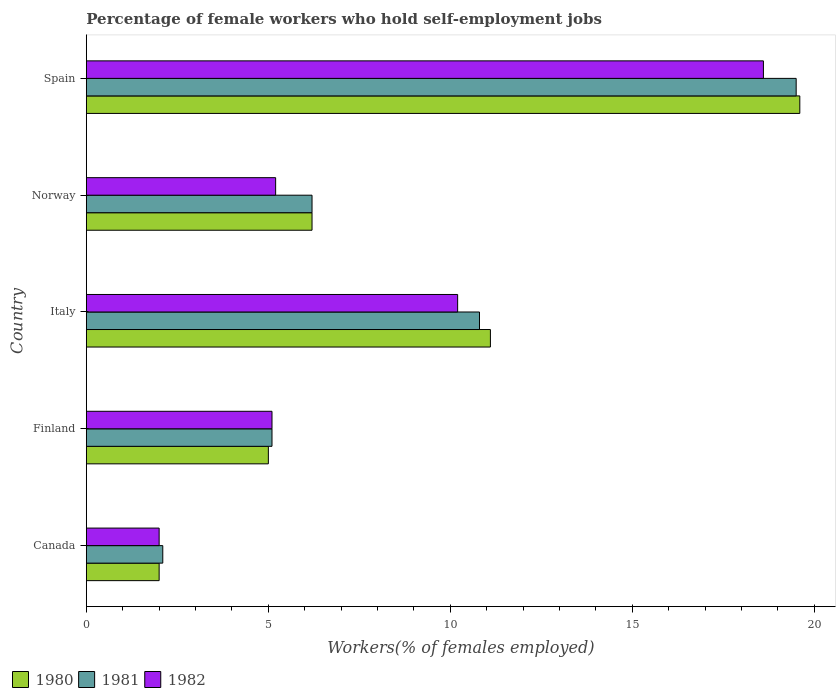Are the number of bars per tick equal to the number of legend labels?
Offer a very short reply. Yes. Are the number of bars on each tick of the Y-axis equal?
Offer a very short reply. Yes. How many bars are there on the 5th tick from the top?
Give a very brief answer. 3. What is the label of the 3rd group of bars from the top?
Provide a short and direct response. Italy. What is the percentage of self-employed female workers in 1981 in Finland?
Give a very brief answer. 5.1. In which country was the percentage of self-employed female workers in 1980 maximum?
Keep it short and to the point. Spain. What is the total percentage of self-employed female workers in 1982 in the graph?
Provide a succinct answer. 41.1. What is the difference between the percentage of self-employed female workers in 1981 in Canada and that in Finland?
Offer a very short reply. -3. What is the difference between the percentage of self-employed female workers in 1981 in Norway and the percentage of self-employed female workers in 1980 in Finland?
Your answer should be very brief. 1.2. What is the average percentage of self-employed female workers in 1980 per country?
Your answer should be compact. 8.78. What is the difference between the percentage of self-employed female workers in 1980 and percentage of self-employed female workers in 1982 in Finland?
Your answer should be very brief. -0.1. What is the ratio of the percentage of self-employed female workers in 1981 in Norway to that in Spain?
Ensure brevity in your answer.  0.32. Is the percentage of self-employed female workers in 1980 in Canada less than that in Norway?
Give a very brief answer. Yes. What is the difference between the highest and the second highest percentage of self-employed female workers in 1981?
Provide a short and direct response. 8.7. What is the difference between the highest and the lowest percentage of self-employed female workers in 1980?
Offer a terse response. 17.6. In how many countries, is the percentage of self-employed female workers in 1982 greater than the average percentage of self-employed female workers in 1982 taken over all countries?
Keep it short and to the point. 2. Is it the case that in every country, the sum of the percentage of self-employed female workers in 1982 and percentage of self-employed female workers in 1980 is greater than the percentage of self-employed female workers in 1981?
Your answer should be very brief. Yes. How many bars are there?
Ensure brevity in your answer.  15. Are all the bars in the graph horizontal?
Provide a short and direct response. Yes. How many countries are there in the graph?
Offer a terse response. 5. How many legend labels are there?
Ensure brevity in your answer.  3. What is the title of the graph?
Ensure brevity in your answer.  Percentage of female workers who hold self-employment jobs. Does "1974" appear as one of the legend labels in the graph?
Give a very brief answer. No. What is the label or title of the X-axis?
Ensure brevity in your answer.  Workers(% of females employed). What is the label or title of the Y-axis?
Provide a succinct answer. Country. What is the Workers(% of females employed) of 1981 in Canada?
Your answer should be very brief. 2.1. What is the Workers(% of females employed) in 1981 in Finland?
Provide a short and direct response. 5.1. What is the Workers(% of females employed) in 1982 in Finland?
Provide a short and direct response. 5.1. What is the Workers(% of females employed) in 1980 in Italy?
Ensure brevity in your answer.  11.1. What is the Workers(% of females employed) of 1981 in Italy?
Your answer should be compact. 10.8. What is the Workers(% of females employed) of 1982 in Italy?
Keep it short and to the point. 10.2. What is the Workers(% of females employed) in 1980 in Norway?
Your answer should be very brief. 6.2. What is the Workers(% of females employed) of 1981 in Norway?
Offer a very short reply. 6.2. What is the Workers(% of females employed) of 1982 in Norway?
Your answer should be compact. 5.2. What is the Workers(% of females employed) of 1980 in Spain?
Give a very brief answer. 19.6. What is the Workers(% of females employed) of 1982 in Spain?
Your answer should be compact. 18.6. Across all countries, what is the maximum Workers(% of females employed) in 1980?
Offer a very short reply. 19.6. Across all countries, what is the maximum Workers(% of females employed) in 1982?
Your response must be concise. 18.6. Across all countries, what is the minimum Workers(% of females employed) of 1981?
Your answer should be very brief. 2.1. Across all countries, what is the minimum Workers(% of females employed) of 1982?
Ensure brevity in your answer.  2. What is the total Workers(% of females employed) in 1980 in the graph?
Offer a terse response. 43.9. What is the total Workers(% of females employed) in 1981 in the graph?
Make the answer very short. 43.7. What is the total Workers(% of females employed) in 1982 in the graph?
Your answer should be very brief. 41.1. What is the difference between the Workers(% of females employed) in 1981 in Canada and that in Finland?
Provide a short and direct response. -3. What is the difference between the Workers(% of females employed) of 1982 in Canada and that in Finland?
Offer a terse response. -3.1. What is the difference between the Workers(% of females employed) in 1980 in Canada and that in Norway?
Your response must be concise. -4.2. What is the difference between the Workers(% of females employed) of 1981 in Canada and that in Norway?
Ensure brevity in your answer.  -4.1. What is the difference between the Workers(% of females employed) in 1980 in Canada and that in Spain?
Provide a short and direct response. -17.6. What is the difference between the Workers(% of females employed) of 1981 in Canada and that in Spain?
Give a very brief answer. -17.4. What is the difference between the Workers(% of females employed) of 1982 in Canada and that in Spain?
Give a very brief answer. -16.6. What is the difference between the Workers(% of females employed) of 1982 in Finland and that in Italy?
Give a very brief answer. -5.1. What is the difference between the Workers(% of females employed) of 1981 in Finland and that in Norway?
Your answer should be compact. -1.1. What is the difference between the Workers(% of females employed) of 1982 in Finland and that in Norway?
Your answer should be compact. -0.1. What is the difference between the Workers(% of females employed) of 1980 in Finland and that in Spain?
Your response must be concise. -14.6. What is the difference between the Workers(% of females employed) of 1981 in Finland and that in Spain?
Give a very brief answer. -14.4. What is the difference between the Workers(% of females employed) of 1980 in Italy and that in Norway?
Your response must be concise. 4.9. What is the difference between the Workers(% of females employed) of 1981 in Italy and that in Norway?
Offer a terse response. 4.6. What is the difference between the Workers(% of females employed) in 1982 in Italy and that in Norway?
Ensure brevity in your answer.  5. What is the difference between the Workers(% of females employed) of 1980 in Italy and that in Spain?
Offer a very short reply. -8.5. What is the difference between the Workers(% of females employed) of 1980 in Norway and that in Spain?
Provide a short and direct response. -13.4. What is the difference between the Workers(% of females employed) of 1981 in Norway and that in Spain?
Offer a terse response. -13.3. What is the difference between the Workers(% of females employed) in 1982 in Norway and that in Spain?
Your answer should be compact. -13.4. What is the difference between the Workers(% of females employed) of 1980 in Canada and the Workers(% of females employed) of 1981 in Finland?
Provide a succinct answer. -3.1. What is the difference between the Workers(% of females employed) of 1980 in Canada and the Workers(% of females employed) of 1981 in Italy?
Provide a succinct answer. -8.8. What is the difference between the Workers(% of females employed) in 1981 in Canada and the Workers(% of females employed) in 1982 in Italy?
Ensure brevity in your answer.  -8.1. What is the difference between the Workers(% of females employed) in 1980 in Canada and the Workers(% of females employed) in 1982 in Norway?
Your answer should be compact. -3.2. What is the difference between the Workers(% of females employed) in 1980 in Canada and the Workers(% of females employed) in 1981 in Spain?
Ensure brevity in your answer.  -17.5. What is the difference between the Workers(% of females employed) in 1980 in Canada and the Workers(% of females employed) in 1982 in Spain?
Offer a terse response. -16.6. What is the difference between the Workers(% of females employed) of 1981 in Canada and the Workers(% of females employed) of 1982 in Spain?
Give a very brief answer. -16.5. What is the difference between the Workers(% of females employed) of 1981 in Finland and the Workers(% of females employed) of 1982 in Italy?
Offer a terse response. -5.1. What is the difference between the Workers(% of females employed) in 1980 in Finland and the Workers(% of females employed) in 1982 in Norway?
Give a very brief answer. -0.2. What is the difference between the Workers(% of females employed) of 1981 in Finland and the Workers(% of females employed) of 1982 in Norway?
Ensure brevity in your answer.  -0.1. What is the difference between the Workers(% of females employed) of 1980 in Finland and the Workers(% of females employed) of 1981 in Spain?
Your answer should be very brief. -14.5. What is the difference between the Workers(% of females employed) of 1980 in Finland and the Workers(% of females employed) of 1982 in Spain?
Keep it short and to the point. -13.6. What is the difference between the Workers(% of females employed) in 1981 in Finland and the Workers(% of females employed) in 1982 in Spain?
Offer a very short reply. -13.5. What is the difference between the Workers(% of females employed) in 1980 in Italy and the Workers(% of females employed) in 1981 in Norway?
Offer a terse response. 4.9. What is the difference between the Workers(% of females employed) in 1980 in Italy and the Workers(% of females employed) in 1981 in Spain?
Keep it short and to the point. -8.4. What is the difference between the Workers(% of females employed) of 1980 in Italy and the Workers(% of females employed) of 1982 in Spain?
Provide a succinct answer. -7.5. What is the difference between the Workers(% of females employed) in 1981 in Italy and the Workers(% of females employed) in 1982 in Spain?
Make the answer very short. -7.8. What is the difference between the Workers(% of females employed) of 1980 in Norway and the Workers(% of females employed) of 1981 in Spain?
Your answer should be compact. -13.3. What is the difference between the Workers(% of females employed) in 1981 in Norway and the Workers(% of females employed) in 1982 in Spain?
Your answer should be compact. -12.4. What is the average Workers(% of females employed) in 1980 per country?
Provide a short and direct response. 8.78. What is the average Workers(% of females employed) in 1981 per country?
Make the answer very short. 8.74. What is the average Workers(% of females employed) in 1982 per country?
Provide a short and direct response. 8.22. What is the difference between the Workers(% of females employed) in 1980 and Workers(% of females employed) in 1981 in Canada?
Your response must be concise. -0.1. What is the difference between the Workers(% of females employed) of 1980 and Workers(% of females employed) of 1982 in Canada?
Give a very brief answer. 0. What is the difference between the Workers(% of females employed) in 1981 and Workers(% of females employed) in 1982 in Canada?
Provide a succinct answer. 0.1. What is the difference between the Workers(% of females employed) in 1980 and Workers(% of females employed) in 1982 in Finland?
Provide a succinct answer. -0.1. What is the difference between the Workers(% of females employed) in 1981 and Workers(% of females employed) in 1982 in Finland?
Offer a very short reply. 0. What is the difference between the Workers(% of females employed) in 1981 and Workers(% of females employed) in 1982 in Spain?
Keep it short and to the point. 0.9. What is the ratio of the Workers(% of females employed) of 1980 in Canada to that in Finland?
Ensure brevity in your answer.  0.4. What is the ratio of the Workers(% of females employed) of 1981 in Canada to that in Finland?
Ensure brevity in your answer.  0.41. What is the ratio of the Workers(% of females employed) in 1982 in Canada to that in Finland?
Provide a succinct answer. 0.39. What is the ratio of the Workers(% of females employed) in 1980 in Canada to that in Italy?
Provide a succinct answer. 0.18. What is the ratio of the Workers(% of females employed) of 1981 in Canada to that in Italy?
Your answer should be very brief. 0.19. What is the ratio of the Workers(% of females employed) of 1982 in Canada to that in Italy?
Offer a terse response. 0.2. What is the ratio of the Workers(% of females employed) of 1980 in Canada to that in Norway?
Keep it short and to the point. 0.32. What is the ratio of the Workers(% of females employed) of 1981 in Canada to that in Norway?
Your answer should be compact. 0.34. What is the ratio of the Workers(% of females employed) in 1982 in Canada to that in Norway?
Your response must be concise. 0.38. What is the ratio of the Workers(% of females employed) of 1980 in Canada to that in Spain?
Ensure brevity in your answer.  0.1. What is the ratio of the Workers(% of females employed) of 1981 in Canada to that in Spain?
Your response must be concise. 0.11. What is the ratio of the Workers(% of females employed) of 1982 in Canada to that in Spain?
Make the answer very short. 0.11. What is the ratio of the Workers(% of females employed) of 1980 in Finland to that in Italy?
Your answer should be very brief. 0.45. What is the ratio of the Workers(% of females employed) of 1981 in Finland to that in Italy?
Offer a terse response. 0.47. What is the ratio of the Workers(% of females employed) of 1980 in Finland to that in Norway?
Offer a very short reply. 0.81. What is the ratio of the Workers(% of females employed) of 1981 in Finland to that in Norway?
Your response must be concise. 0.82. What is the ratio of the Workers(% of females employed) in 1982 in Finland to that in Norway?
Keep it short and to the point. 0.98. What is the ratio of the Workers(% of females employed) of 1980 in Finland to that in Spain?
Your answer should be very brief. 0.26. What is the ratio of the Workers(% of females employed) in 1981 in Finland to that in Spain?
Your answer should be compact. 0.26. What is the ratio of the Workers(% of females employed) of 1982 in Finland to that in Spain?
Offer a terse response. 0.27. What is the ratio of the Workers(% of females employed) in 1980 in Italy to that in Norway?
Offer a terse response. 1.79. What is the ratio of the Workers(% of females employed) of 1981 in Italy to that in Norway?
Make the answer very short. 1.74. What is the ratio of the Workers(% of females employed) of 1982 in Italy to that in Norway?
Keep it short and to the point. 1.96. What is the ratio of the Workers(% of females employed) of 1980 in Italy to that in Spain?
Make the answer very short. 0.57. What is the ratio of the Workers(% of females employed) of 1981 in Italy to that in Spain?
Your answer should be compact. 0.55. What is the ratio of the Workers(% of females employed) in 1982 in Italy to that in Spain?
Offer a terse response. 0.55. What is the ratio of the Workers(% of females employed) of 1980 in Norway to that in Spain?
Offer a very short reply. 0.32. What is the ratio of the Workers(% of females employed) of 1981 in Norway to that in Spain?
Provide a short and direct response. 0.32. What is the ratio of the Workers(% of females employed) of 1982 in Norway to that in Spain?
Make the answer very short. 0.28. What is the difference between the highest and the second highest Workers(% of females employed) of 1980?
Your response must be concise. 8.5. What is the difference between the highest and the second highest Workers(% of females employed) in 1981?
Your answer should be compact. 8.7. What is the difference between the highest and the second highest Workers(% of females employed) of 1982?
Your answer should be compact. 8.4. What is the difference between the highest and the lowest Workers(% of females employed) of 1980?
Your answer should be very brief. 17.6. What is the difference between the highest and the lowest Workers(% of females employed) of 1981?
Your response must be concise. 17.4. 